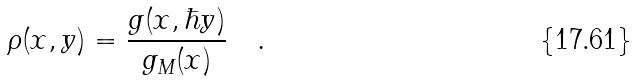<formula> <loc_0><loc_0><loc_500><loc_500>\rho _ { } ( x , y ) = \frac { g ( x , \hbar { y } ) } { g _ { M } ( x ) } \quad .</formula> 